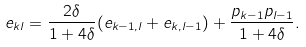Convert formula to latex. <formula><loc_0><loc_0><loc_500><loc_500>e _ { k l } = \frac { 2 \delta } { 1 + 4 \delta } ( e _ { k - 1 , l } + e _ { k , l - 1 } ) + \frac { p _ { k - 1 } p _ { l - 1 } } { 1 + 4 \delta } .</formula> 